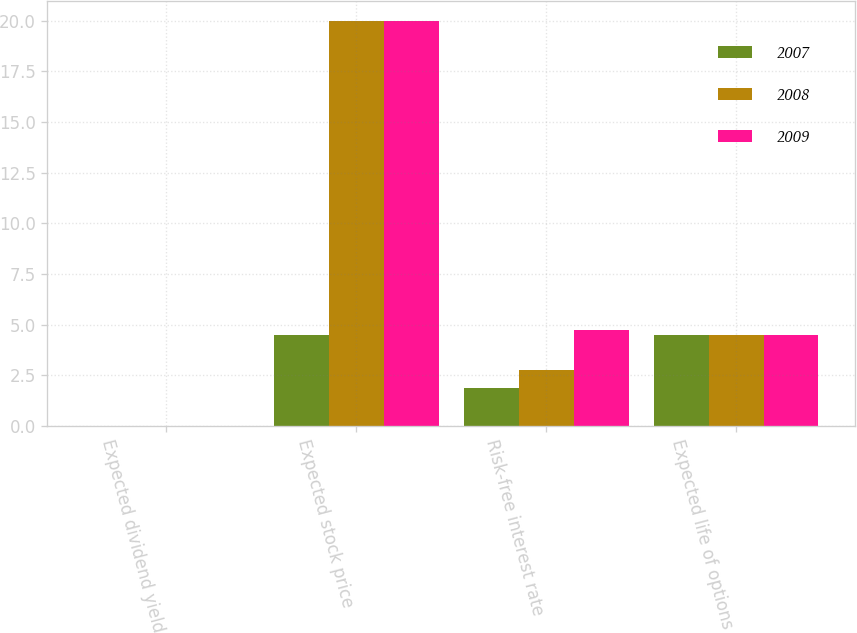<chart> <loc_0><loc_0><loc_500><loc_500><stacked_bar_chart><ecel><fcel>Expected dividend yield<fcel>Expected stock price<fcel>Risk-free interest rate<fcel>Expected life of options<nl><fcel>2007<fcel>0<fcel>4.5<fcel>1.88<fcel>4.5<nl><fcel>2008<fcel>0<fcel>20<fcel>2.75<fcel>4.5<nl><fcel>2009<fcel>0<fcel>20<fcel>4.75<fcel>4.5<nl></chart> 